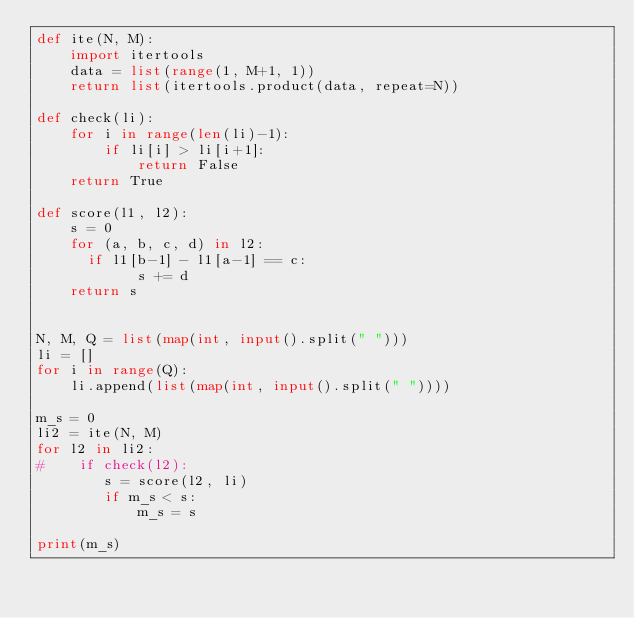<code> <loc_0><loc_0><loc_500><loc_500><_Python_>def ite(N, M):
    import itertools
    data = list(range(1, M+1, 1))
    return list(itertools.product(data, repeat=N))
  
def check(li):
    for i in range(len(li)-1):
        if li[i] > li[i+1]:
            return False
    return True
    
def score(l1, l2):
    s = 0
    for (a, b, c, d) in l2:
      if l1[b-1] - l1[a-1] == c:
            s += d
    return s
        

N, M, Q = list(map(int, input().split(" ")))
li = []
for i in range(Q):
    li.append(list(map(int, input().split(" "))))

m_s = 0
li2 = ite(N, M) 
for l2 in li2:
#    if check(l2):
        s = score(l2, li)
        if m_s < s:
            m_s = s
            
print(m_s)</code> 